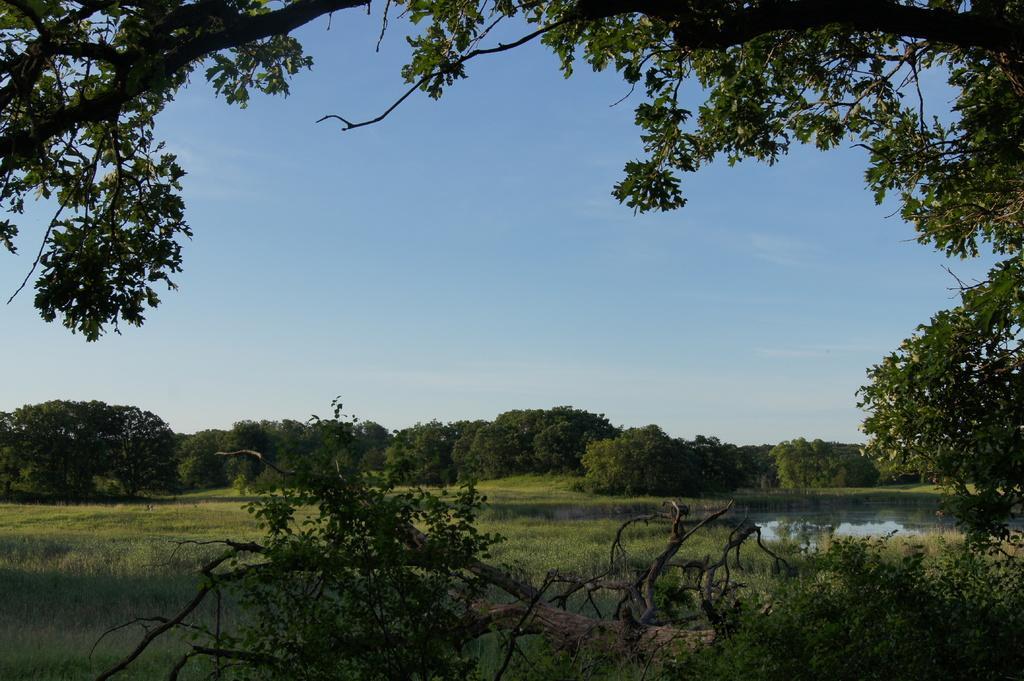Describe this image in one or two sentences. In this image we can see a group of trees, grass and water. In the background, we can see the sky. 